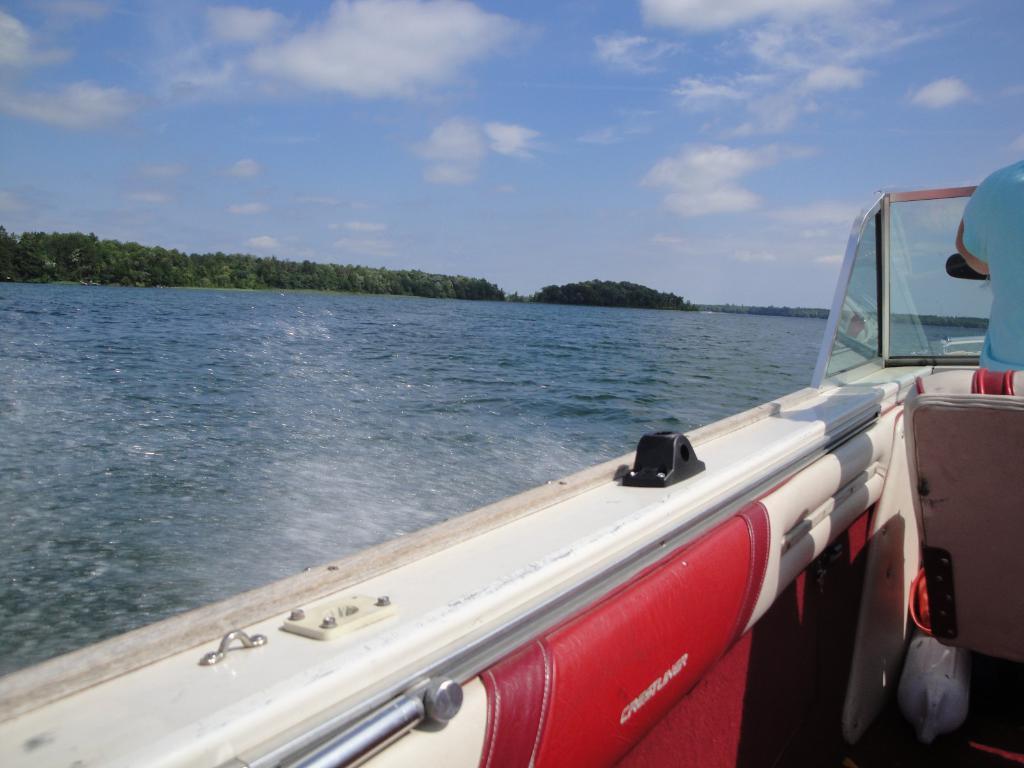How would you summarize this image in a sentence or two? At the bottom there is a boat. On the right there is a man who is wearing t-shirt and he is riding a boat on the water. in the background I can see many trees, mountain and river. At the top I can see the sky and clouds. 